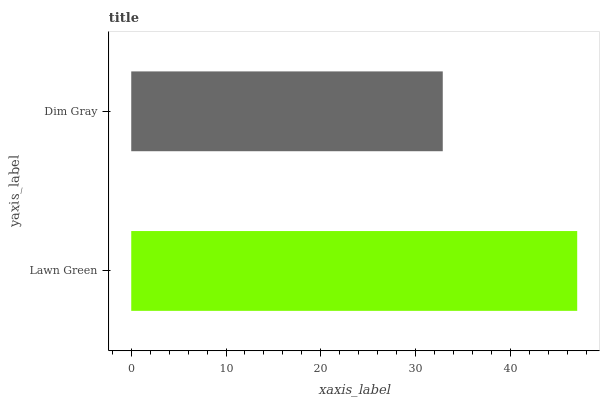Is Dim Gray the minimum?
Answer yes or no. Yes. Is Lawn Green the maximum?
Answer yes or no. Yes. Is Dim Gray the maximum?
Answer yes or no. No. Is Lawn Green greater than Dim Gray?
Answer yes or no. Yes. Is Dim Gray less than Lawn Green?
Answer yes or no. Yes. Is Dim Gray greater than Lawn Green?
Answer yes or no. No. Is Lawn Green less than Dim Gray?
Answer yes or no. No. Is Lawn Green the high median?
Answer yes or no. Yes. Is Dim Gray the low median?
Answer yes or no. Yes. Is Dim Gray the high median?
Answer yes or no. No. Is Lawn Green the low median?
Answer yes or no. No. 